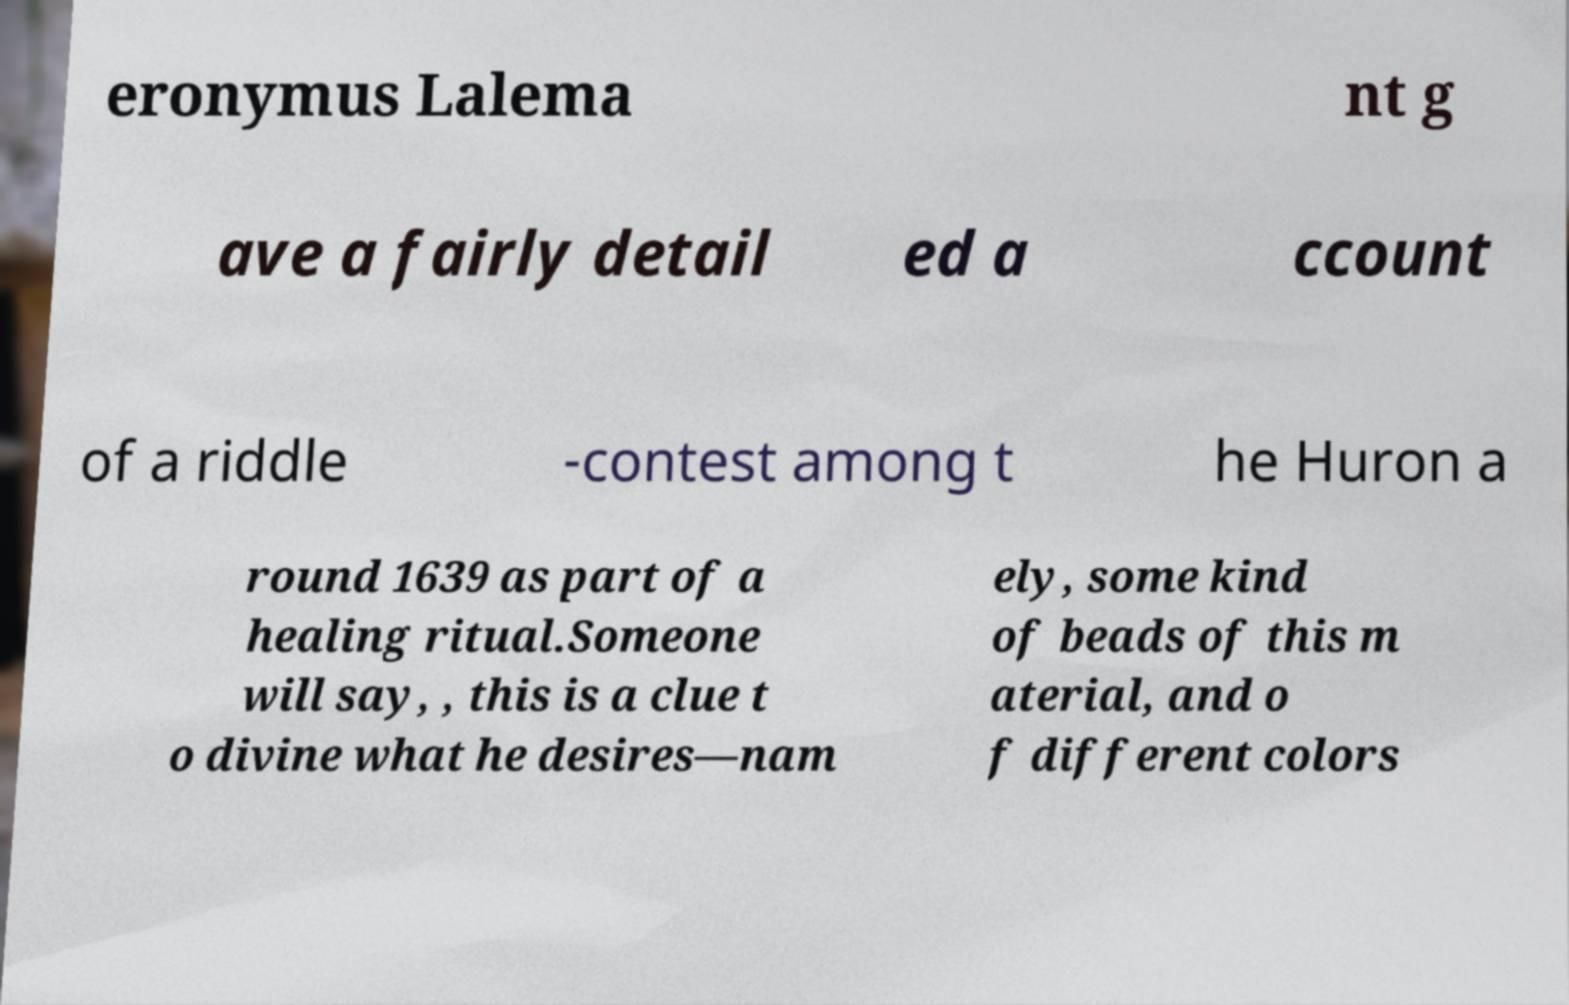Can you accurately transcribe the text from the provided image for me? eronymus Lalema nt g ave a fairly detail ed a ccount of a riddle -contest among t he Huron a round 1639 as part of a healing ritual.Someone will say, , this is a clue t o divine what he desires—nam ely, some kind of beads of this m aterial, and o f different colors 